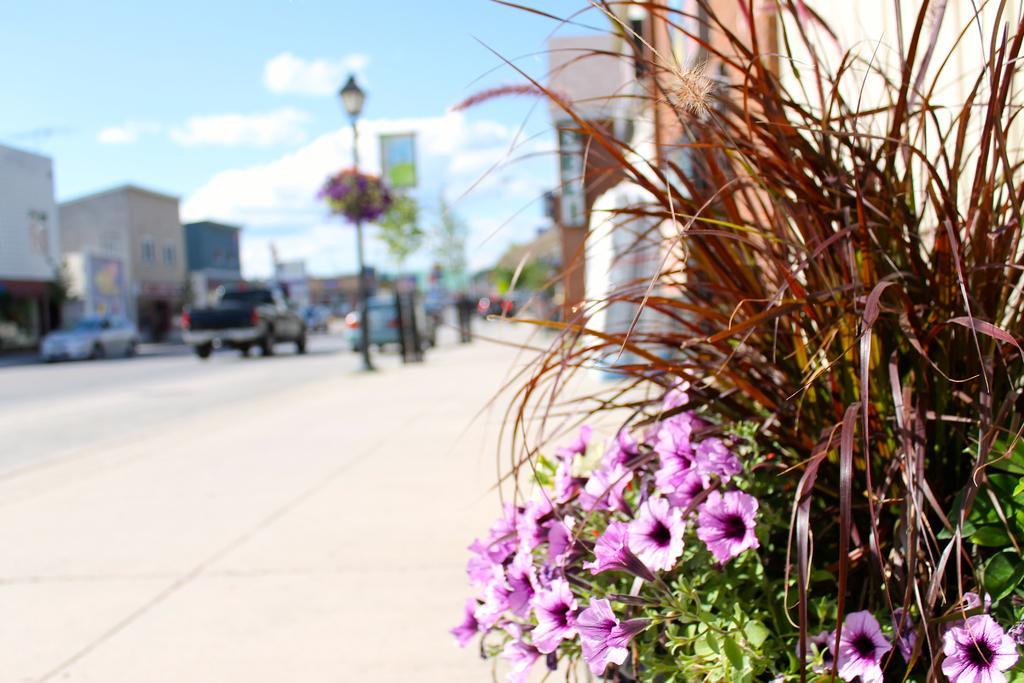Please provide a concise description of this image. In this image, in the right corner, we can see plant with some flowers and the flowers are in pink in color. On the right side, we can also see a building, board. In the middle of the image, we can see a street light, pole, plant with some flowers, plants and a board. On the left side, we can see few vehicles which are moving on the road. On the left side, we can see some buildings, window. In the background, we can see some trees, buildings. At the top, we can see a sky which is a bit cloudy, at the bottom, we can see a road and a footpath. 